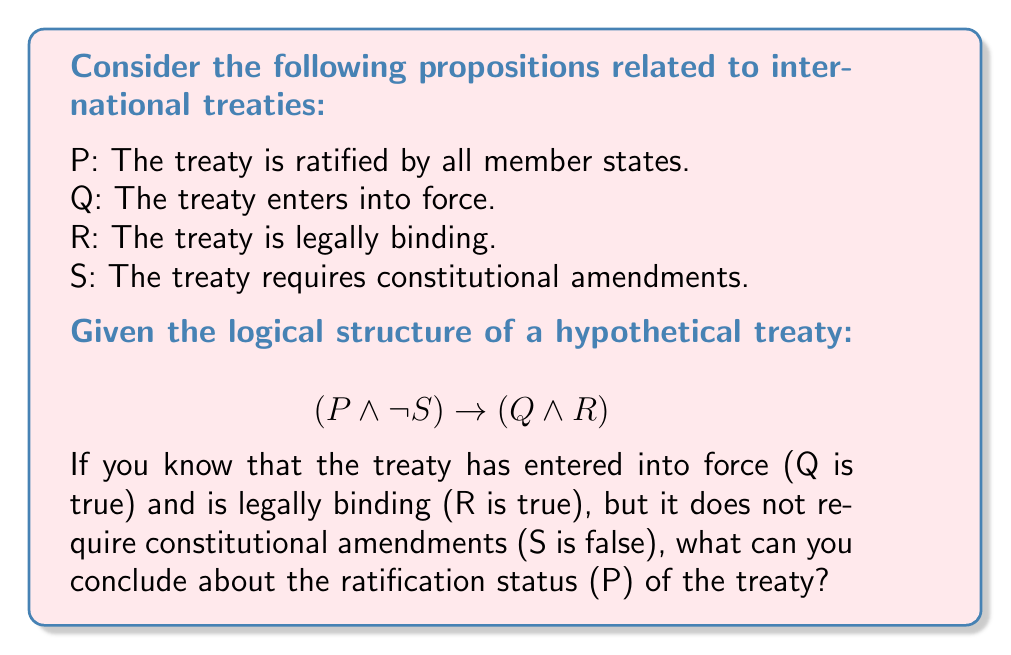Show me your answer to this math problem. Let's approach this step-by-step using propositional logic:

1) We are given that Q is true, R is true, and S is false.

2) The logical structure of the treaty is: $$(P \land \neg S) \to (Q \land R)$$

3) We know that (Q ∧ R) is true because both Q and R are true.

4) In propositional logic, if A → B and B is true, we cannot conclude anything definitive about A. This is because the implication is still true if A is false (vacuously true implication).

5) However, we can use the additional information that S is false.

6) $\neg S$ is therefore true.

7) For the implication to be true, either $(P \land \neg S)$ must be true, or $(Q \land R)$ must be true (or both).

8) We know $(Q \land R)$ is true, so the implication holds regardless of the truth value of P.

9) Therefore, based on the given information, we cannot definitively conclude whether P is true or false. The treaty could have been ratified by all member states (P true) or not (P false), and the logical structure would still hold.
Answer: Cannot be determined 